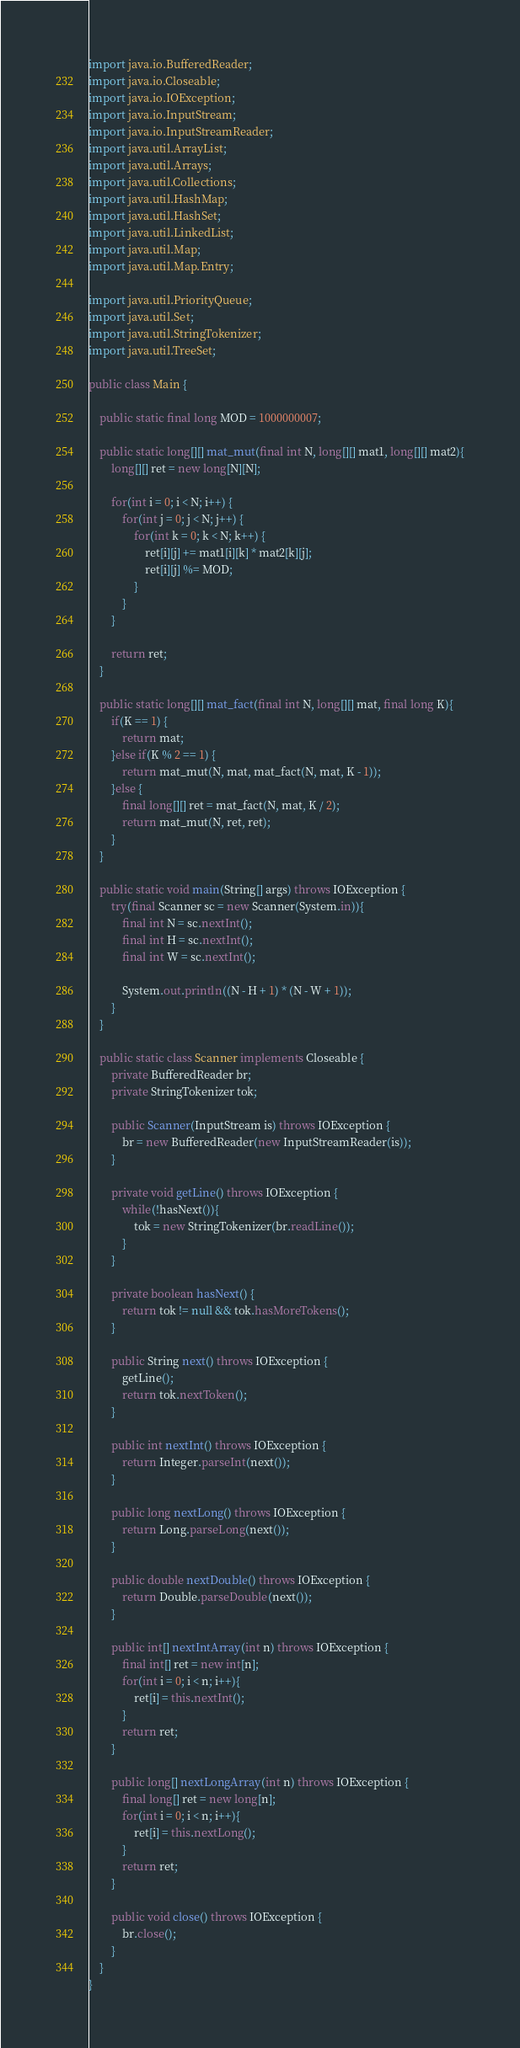Convert code to text. <code><loc_0><loc_0><loc_500><loc_500><_Java_>import java.io.BufferedReader;
import java.io.Closeable;
import java.io.IOException;
import java.io.InputStream;
import java.io.InputStreamReader;
import java.util.ArrayList;
import java.util.Arrays;
import java.util.Collections;
import java.util.HashMap;
import java.util.HashSet;
import java.util.LinkedList;
import java.util.Map;
import java.util.Map.Entry;

import java.util.PriorityQueue;
import java.util.Set;
import java.util.StringTokenizer;
import java.util.TreeSet;
 
public class Main {
	
	public static final long MOD = 1000000007;
	
	public static long[][] mat_mut(final int N, long[][] mat1, long[][] mat2){
		long[][] ret = new long[N][N];
		
		for(int i = 0; i < N; i++) {
			for(int j = 0; j < N; j++) {
				for(int k = 0; k < N; k++) {
					ret[i][j] += mat1[i][k] * mat2[k][j];
					ret[i][j] %= MOD;
				}
			}
		}
		
		return ret;
	}
	
	public static long[][] mat_fact(final int N, long[][] mat, final long K){
		if(K == 1) {
			return mat;
		}else if(K % 2 == 1) {
			return mat_mut(N, mat, mat_fact(N, mat, K - 1));
		}else {
			final long[][] ret = mat_fact(N, mat, K / 2);
			return mat_mut(N, ret, ret);
		}
	}
	
	public static void main(String[] args) throws IOException {
		try(final Scanner sc = new Scanner(System.in)){
			final int N = sc.nextInt();
			final int H = sc.nextInt();
			final int W = sc.nextInt();
			
			System.out.println((N - H + 1) * (N - W + 1));
		}
	}
 
	public static class Scanner implements Closeable {
		private BufferedReader br;
		private StringTokenizer tok;
 
		public Scanner(InputStream is) throws IOException {
			br = new BufferedReader(new InputStreamReader(is));
		}
 
		private void getLine() throws IOException {
			while(!hasNext()){
				tok = new StringTokenizer(br.readLine());
			}
		}
 
		private boolean hasNext() {
			return tok != null && tok.hasMoreTokens();
		}
 
		public String next() throws IOException {
			getLine();
			return tok.nextToken();
		}
 
		public int nextInt() throws IOException {
			return Integer.parseInt(next());
		}
 
		public long nextLong() throws IOException {
			return Long.parseLong(next());
		}
 
		public double nextDouble() throws IOException {
			return Double.parseDouble(next());
		}
 
		public int[] nextIntArray(int n) throws IOException {
			final int[] ret = new int[n];
			for(int i = 0; i < n; i++){
				ret[i] = this.nextInt();
			}
			return ret;
		}
 
		public long[] nextLongArray(int n) throws IOException {
			final long[] ret = new long[n];
			for(int i = 0; i < n; i++){
				ret[i] = this.nextLong();
			}
			return ret;
		}
 
		public void close() throws IOException {
			br.close();
		}
	}
}</code> 